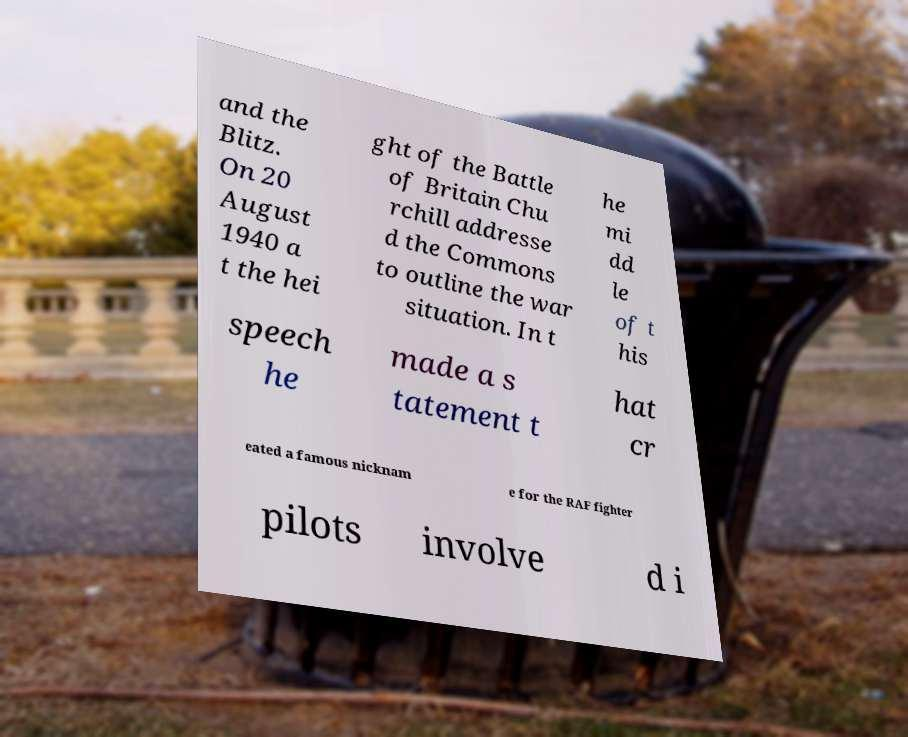For documentation purposes, I need the text within this image transcribed. Could you provide that? and the Blitz. On 20 August 1940 a t the hei ght of the Battle of Britain Chu rchill addresse d the Commons to outline the war situation. In t he mi dd le of t his speech he made a s tatement t hat cr eated a famous nicknam e for the RAF fighter pilots involve d i 